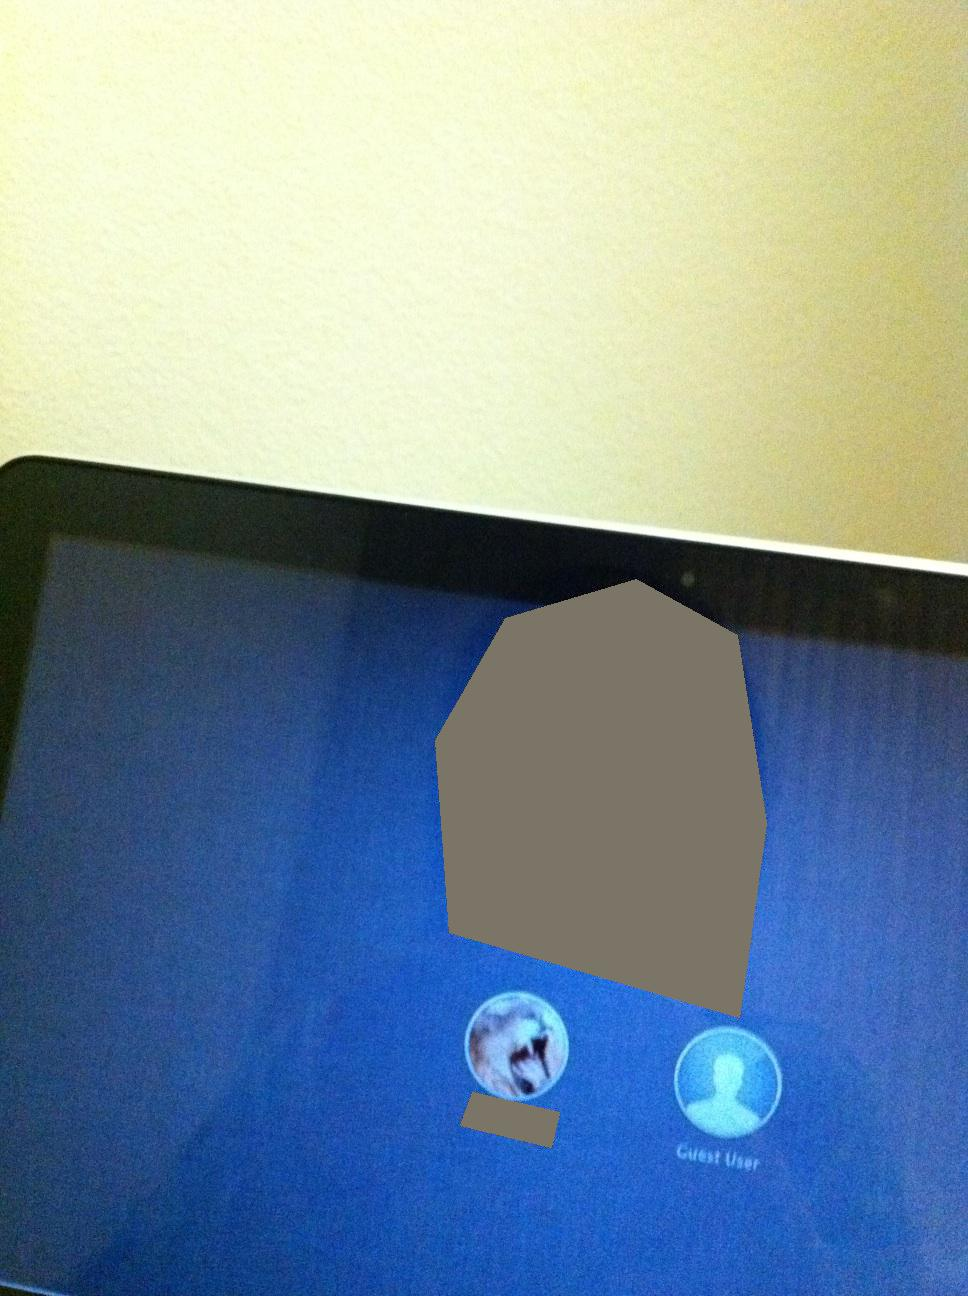If these characters had to address a council of elders, what might they say about their journey and the importance of teamwork? Lyra might stand confidently before the council and recount the challenges they overcame, emphasizing her ability to adapt and grow stronger in the face of adversity. She’d speak of the magical beasts they allied with, the lands they protected, and the enemies they vanquished. Aelan would step up next, highlighting the wisdom gained through their journey. He’d stress the significance of teamwork, narrating how his knowledge and Lyra’s strength complemented each other, leading to victories that wouldn’t have been possible alone. Their message to the council would be clear: Unity in diversity makes for indomitable strength. 